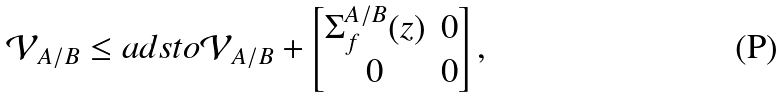<formula> <loc_0><loc_0><loc_500><loc_500>\mathcal { V } _ { A / B } \leq a d s t o \mathcal { V } _ { A / B } + \begin{bmatrix} \Sigma ^ { A / B } _ { f } ( z ) & 0 \\ 0 & 0 \end{bmatrix} ,</formula> 